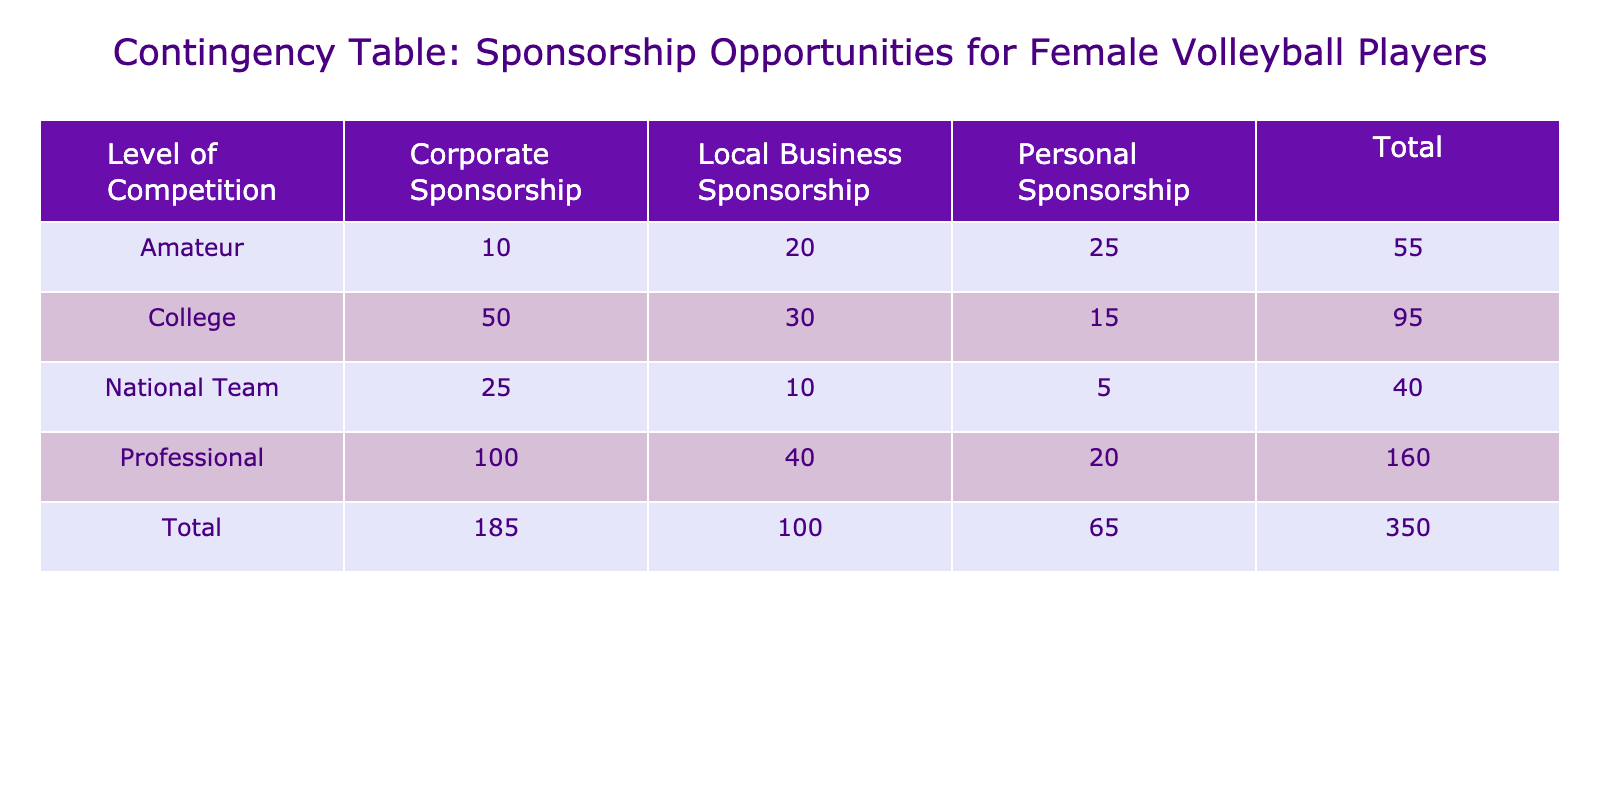What is the total number of sponsored athletes at the college level? From the table, under the "College" row, we need to sum the number of sponsored athletes across all sponsorship types: Corporate (50) + Local Business (30) + Personal (15) = 95.
Answer: 95 What is the average sponsorship amount for female volleyball players in the national team? To find the average sponsorship amount for the national team, we take the amounts for each type of sponsorship: Corporate (20000) + Local Business (7000) + Personal (4000) = 34000. There are three sponsorship types, so we calculate the average: 34000 / 3 = 11333.33.
Answer: 11333.33 Is there a local business sponsorship at the amateur level? Looking at the amateur level in the table, we check the row to see if any sponsorship type is listed as Local Business. Yes, there is a Local Business Sponsorship with 20 sponsored athletes.
Answer: Yes What is the difference in the average sponsorship amount between the professional and college levels? First, calculate the average sponsorship amount for college: (5000*50 + 2000*30 + 1000*15) / (50 + 30 + 15) = (250000 + 60000 + 15000) / 95 = 316315 / 95 = 3327.11. Now for professional: (15000*100 + 5000*40 + 3000*20) / (100 + 40 + 20) = (1500000 + 200000 + 60000) / 160 = 1760000 / 160 = 11000. The difference is 11000 - 3327.11 = 7672.89.
Answer: 7672.89 How many athletes do we have under personal sponsorship overall? We need to sum the number of athletes under Personal Sponsorship across all levels of competition: College (15) + Professional (20) + National Team (5) + Amateur (25) = 15 + 20 + 5 + 25 = 65.
Answer: 65 What is the highest number of sponsored athletes in a single sponsorship type? We examine the table to find the maximum value for each sponsorship type. The maximum number of sponsored athletes occurs in Corporate Sponsorship for the professional level with 100 athletes.
Answer: 100 Are there fewer total athletes sponsored in local business sponsorship compared to personal sponsorship at the amateur level? For the amateur level, we have 20 athletes under Local Business Sponsorship and 25 under Personal Sponsorship. Since 20 is less than 25, the statement is true.
Answer: Yes What is the total sponsorship amount for all athletes in the National Team? Calculate the total sponsorship amounts by multiplying the number of athletes by the average amounts for each type in the National Team: Corporate: 25 * 20000 = 500000, Local Business: 10 * 7000 = 70000, Personal: 5 * 4000 = 20000. Adding them: 500000 + 70000 + 20000 = 590000.
Answer: 590000 What is the total number of sponsored athletes across all levels of competition? To find the total number of athletes, we sum the athletes from all levels and all sponsorship types listed in the table: College (95) + Professional (160) + National Team (40) + Amateur (55) = 95 + 160 + 40 + 55 = 350.
Answer: 350 